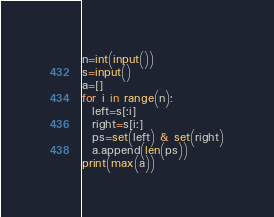<code> <loc_0><loc_0><loc_500><loc_500><_Python_>n=int(input())
s=input()
a=[]
for i in range(n):
  left=s[:i]
  right=s[i:]
  ps=set(left) & set(right)
  a.append(len(ps))
print(max(a))</code> 